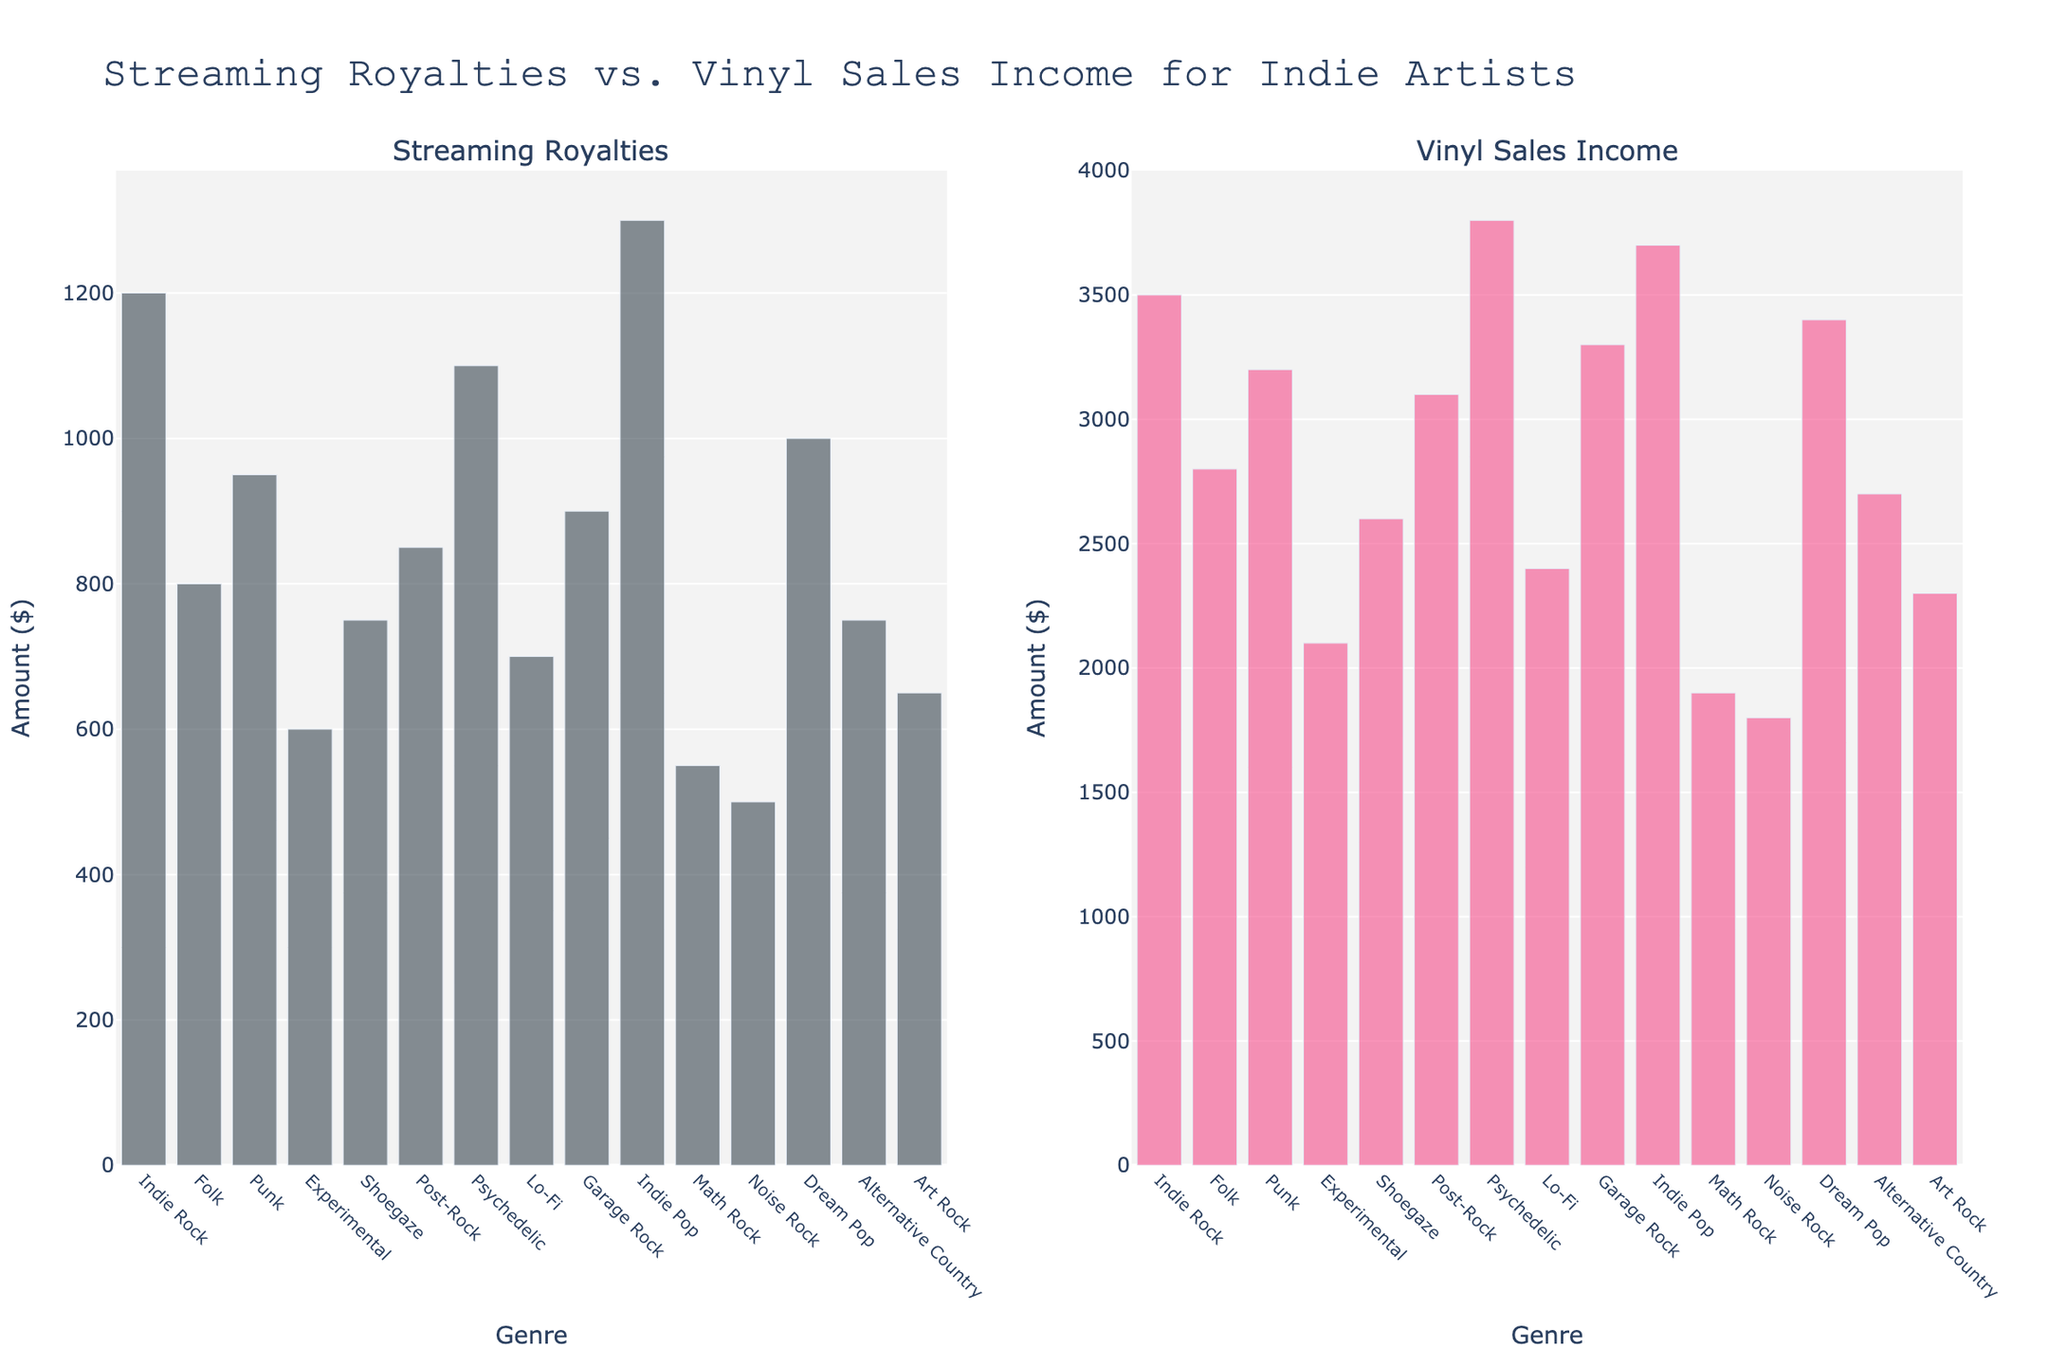Which genre has the highest vinyl sales income? By looking at the heights of the bars in the Vinyl Sales Income subplot, the genre with the tallest bar represents the highest income. The Psychedelic genre has the tallest bar.
Answer: Psychedelic Which genre generates more income from streaming royalties, Indie Pop or Indie Rock? Comparing the heights of the bars for Indie Pop and Indie Rock in the Streaming Royalties subplot, Indie Pop's bar is slightly taller.
Answer: Indie Pop What's the total income for Punk from streaming royalties and vinyl sales? Add the values from the Streaming Royalties subplot and the Vinyl Sales Income subplot for Punk: 950 + 3200 = 4150.
Answer: 4150 Which genre has the lowest streaming royalties? By identifying the shortest bar in the Streaming Royalties subplot, Noise Rock has the shortest bar.
Answer: Noise Rock Compare the income from vinyl sales between Alternative Country and Shoegaze. Which makes more? The height of the bar for Alternative Country in the Vinyl Sales Income subplot is shorter than that for Shoegaze, indicating lower income. Shoegaze has higher vinyl sales income.
Answer: Shoegaze Is the income from vinyl sales for Garage Rock greater than its streaming royalties? By comparing the heights of the corresponding bars for Garage Rock in both subplots, the bar in the Vinyl Sales Income subplot is taller.
Answer: Yes Identify the genre with the most significant difference between vinyl sales income and streaming royalties. Calculate the difference for each genre: 
    - Indie Rock: 3500 - 1200 = 2300
    - Folk: 2800 - 800 = 2000
    - Punk: 3200 - 950 = 2250
    - Experimental: 2100 - 600 = 1500
    - Shoegaze: 2600 - 750 = 1850
    - Post-Rock: 3100 - 850 = 2250
    - Psychedelic: 3800 - 1100 = 2700
    - Lo-Fi: 2400 - 700 = 1700
    - Garage Rock: 3300 - 900 = 2400
    - Indie Pop: 3700 - 1300 = 2400
    - Math Rock: 1900 - 550 = 1350
    - Noise Rock: 1800 - 500 = 1300
    - Dream Pop: 3400 - 1000 = 2400
    - Alternative Country: 2700 - 750 = 1950
    - Art Rock: 2300 - 650 = 1650
    Psychedelic has the highest difference of 2700.
Answer: Psychedelic How does the vinyl sales income for Lo-Fi compare to Experimental? By looking at the heights of the bars in the Vinyl Sales Income subplot, Lo-Fi's bar is taller than Experimental's.
Answer: Lo-Fi What is the combined streaming royalties for genres with less than 700 in streaming royalties? Sum the values for genres with less than 700: 
    - Experimental: 600
    - Math Rock: 550
    - Noise Rock: 500
    Total = 600 + 550 + 500 = 1650
Answer: 1650 For which genre do streaming royalties and vinyl sales income appear most balanced? Identify the genre where the bars for streaming royalties and vinyl sales income are closest in height visually. Indie Pop appears the most balanced visually.
Answer: Indie Pop 